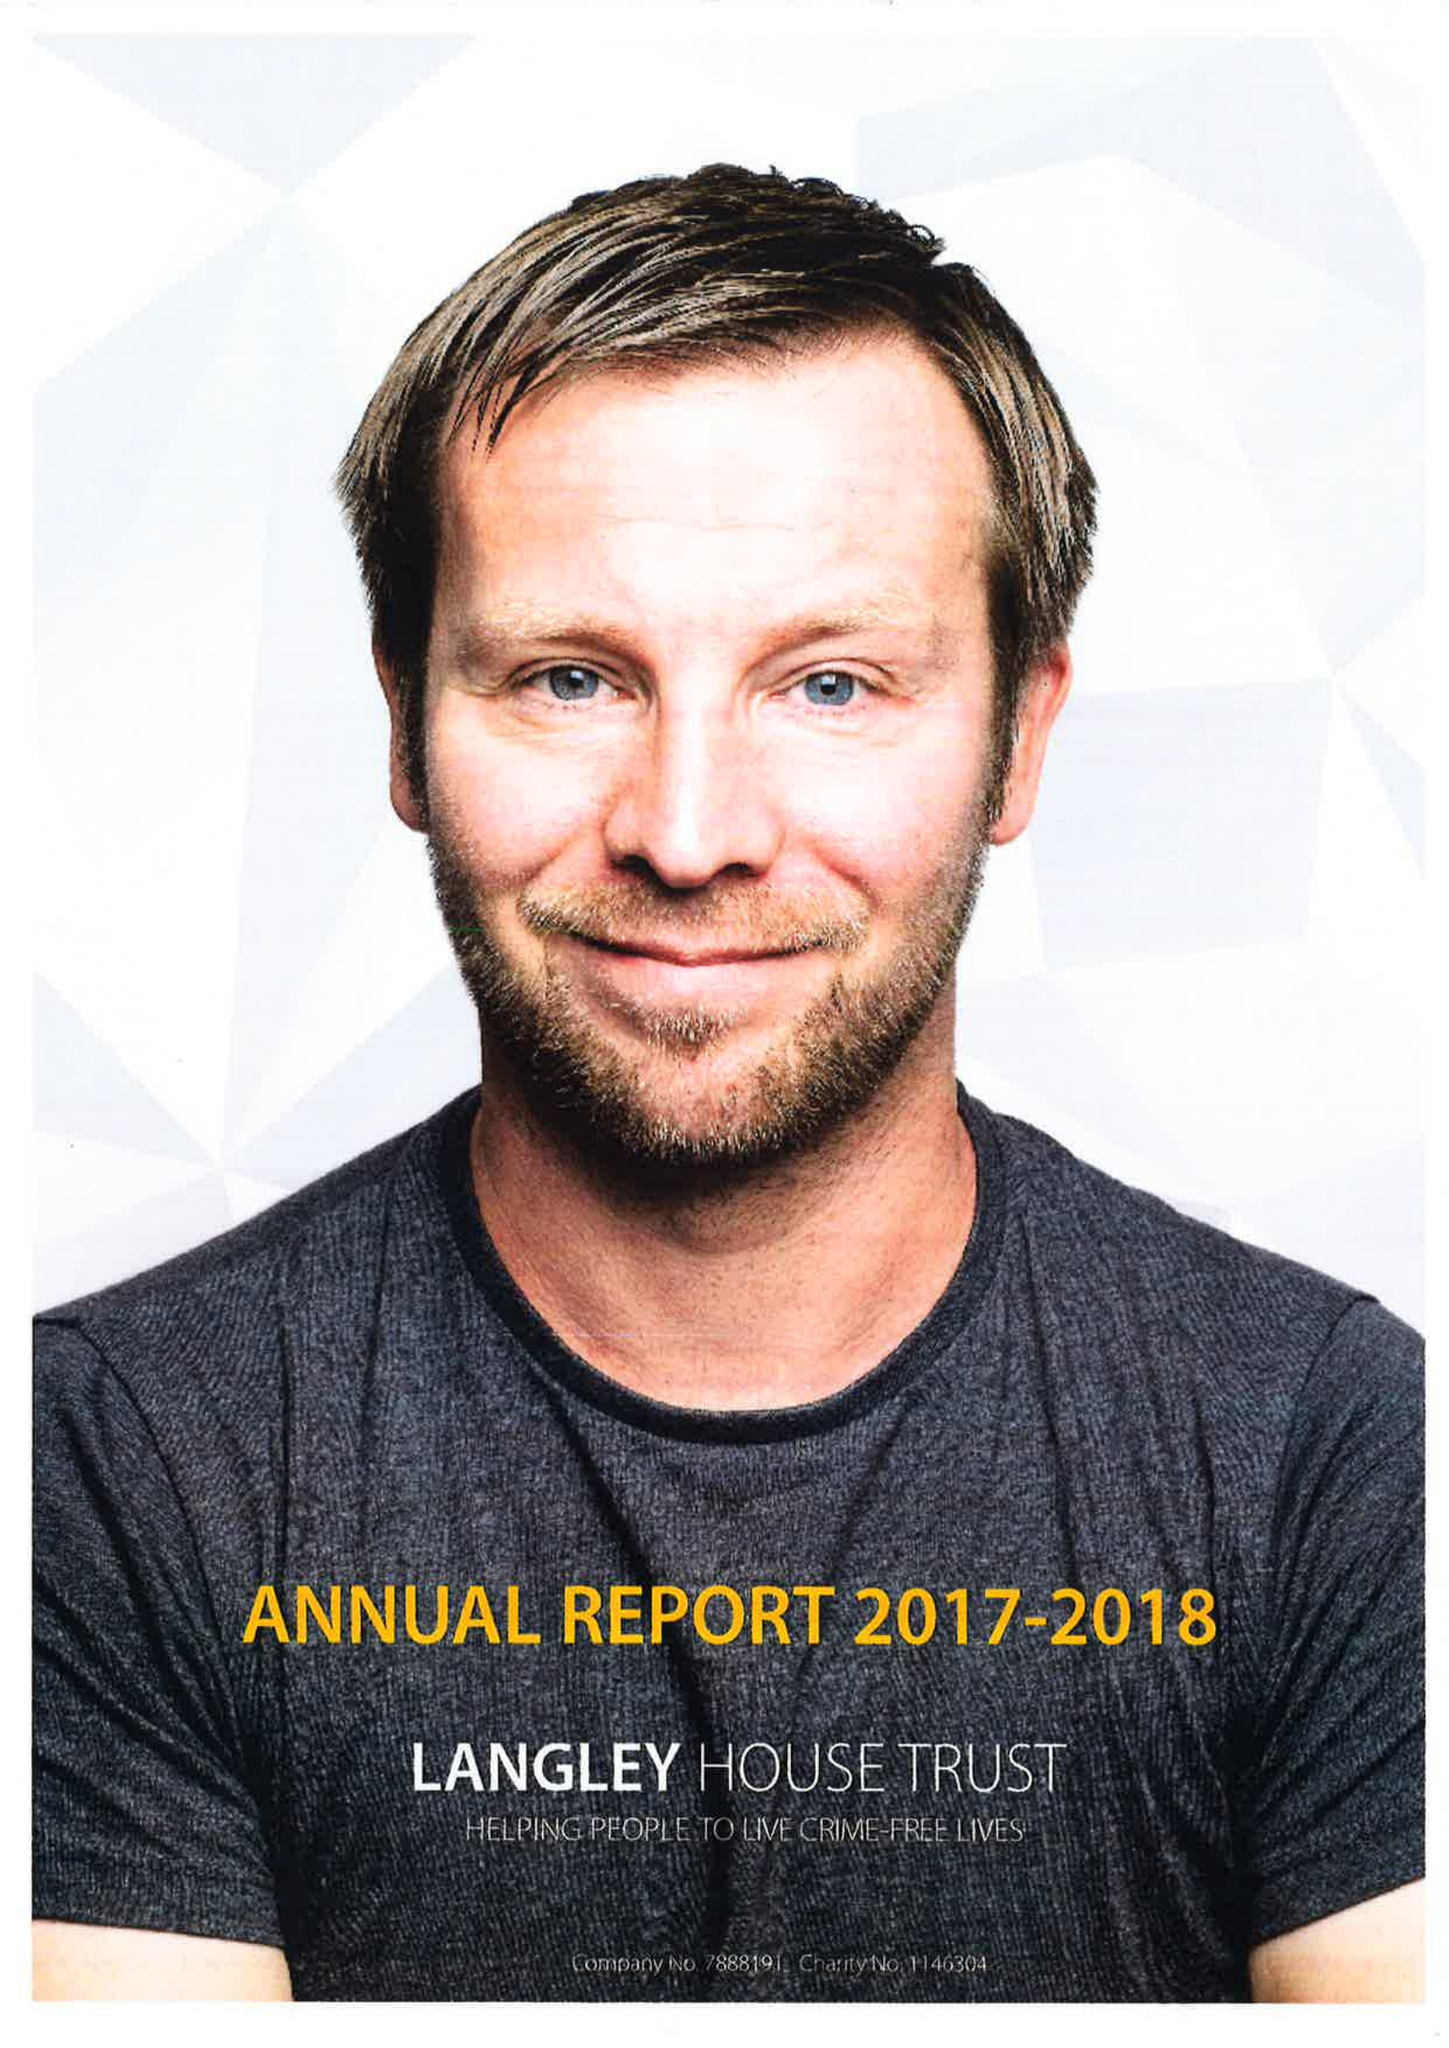What is the value for the address__street_line?
Answer the question using a single word or phrase. None 